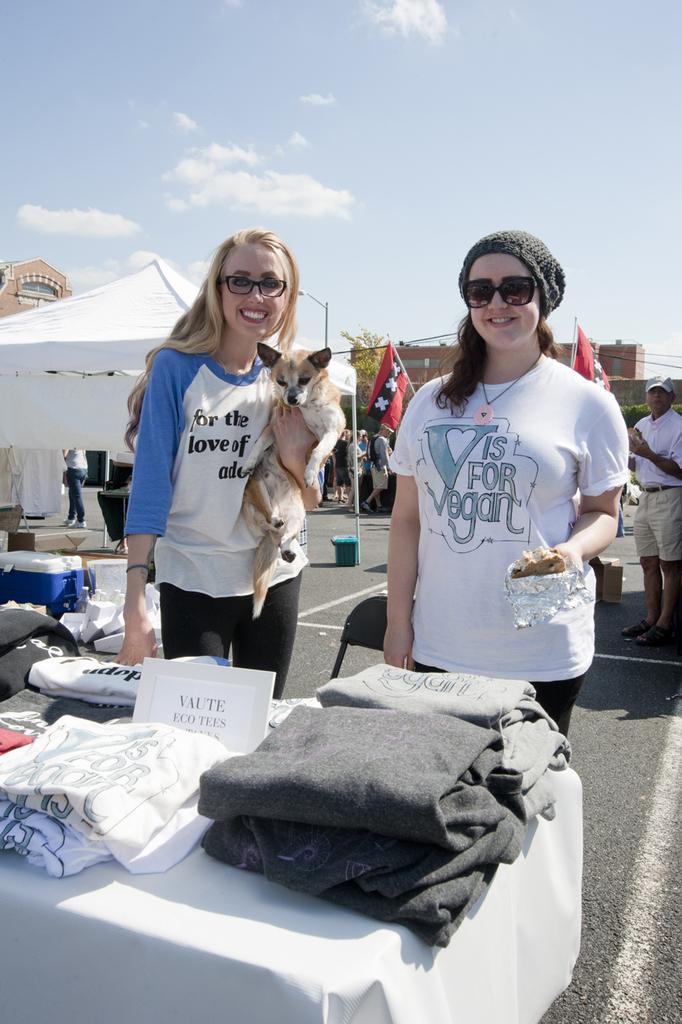How would you summarize this image in a sentence or two? In this image, There is a table covered by a white cloth on that table there are some clothes, And there are two women standing, In the background there is a white color sky and there is a white color shade, In the right side of the image there is a man standing. 